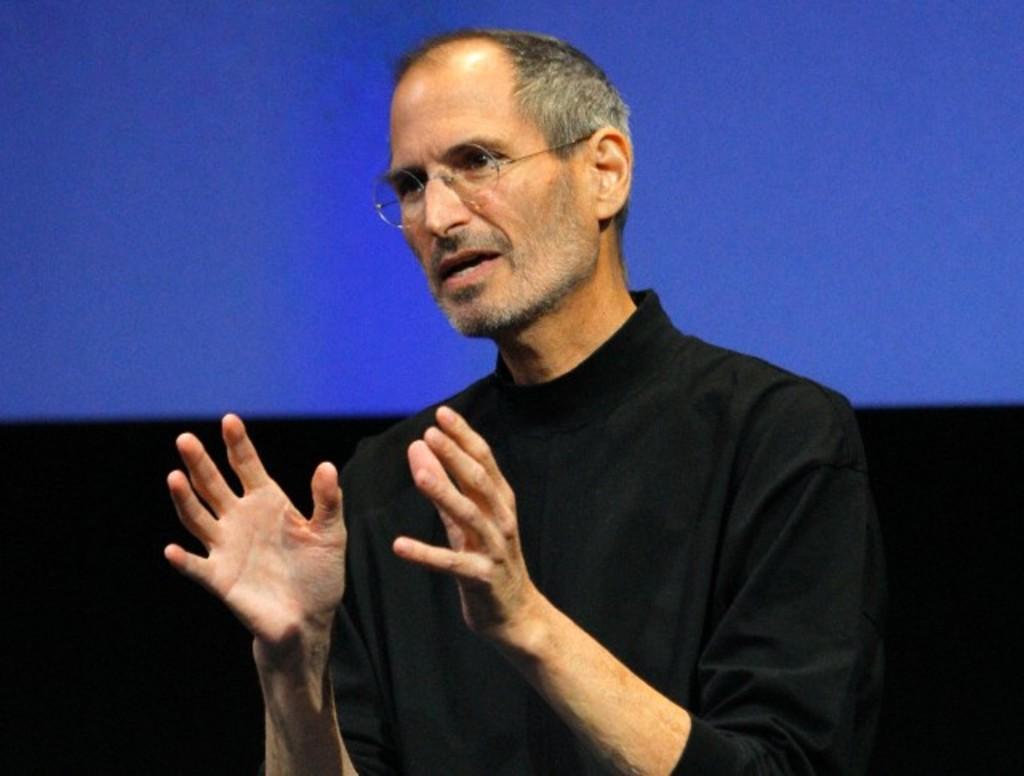Please provide a concise description of this image. In the center of the image there is a person. In the background there is screen. 